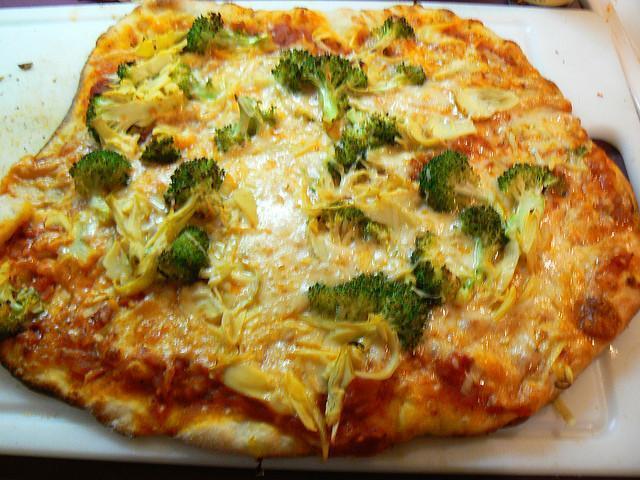How many broccolis are in the picture?
Give a very brief answer. 9. How many people are pushing cart?
Give a very brief answer. 0. 